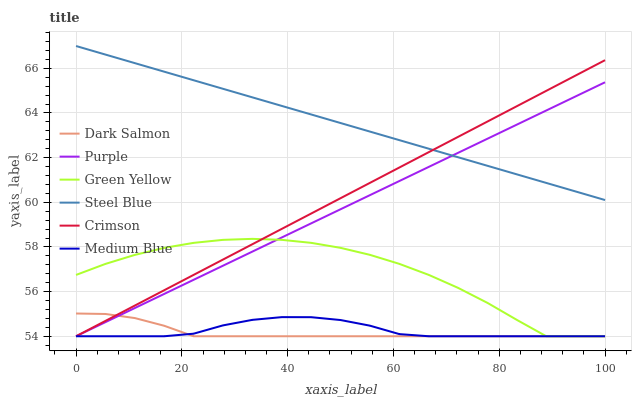Does Dark Salmon have the minimum area under the curve?
Answer yes or no. Yes. Does Steel Blue have the maximum area under the curve?
Answer yes or no. Yes. Does Medium Blue have the minimum area under the curve?
Answer yes or no. No. Does Medium Blue have the maximum area under the curve?
Answer yes or no. No. Is Purple the smoothest?
Answer yes or no. Yes. Is Green Yellow the roughest?
Answer yes or no. Yes. Is Medium Blue the smoothest?
Answer yes or no. No. Is Medium Blue the roughest?
Answer yes or no. No. Does Purple have the lowest value?
Answer yes or no. Yes. Does Steel Blue have the lowest value?
Answer yes or no. No. Does Steel Blue have the highest value?
Answer yes or no. Yes. Does Dark Salmon have the highest value?
Answer yes or no. No. Is Green Yellow less than Steel Blue?
Answer yes or no. Yes. Is Steel Blue greater than Green Yellow?
Answer yes or no. Yes. Does Dark Salmon intersect Crimson?
Answer yes or no. Yes. Is Dark Salmon less than Crimson?
Answer yes or no. No. Is Dark Salmon greater than Crimson?
Answer yes or no. No. Does Green Yellow intersect Steel Blue?
Answer yes or no. No. 